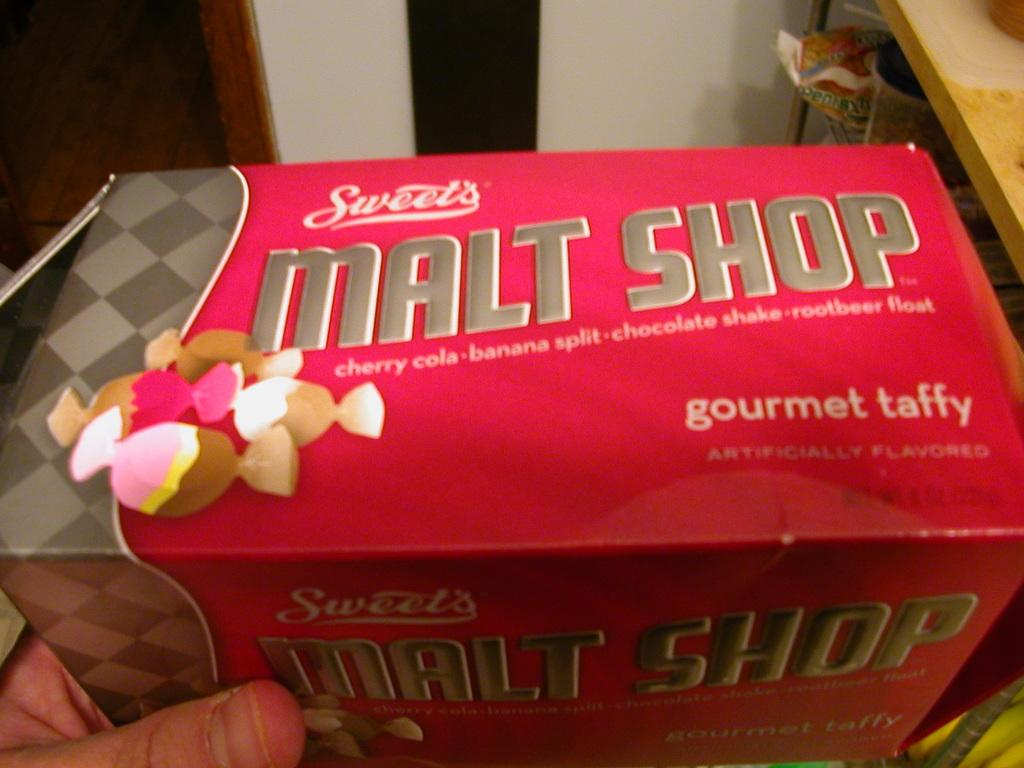What object is the main focus of the image? There is a box in the image. Can you describe any other visible elements in the image? A person's hand is visible in the left corner of the image, and there is a wooden and metal object in the right corner of the image. What can be seen in the background of the image? There appears to be a wall in the background of the image. How many boats are visible in the image? There are no boats present in the image. What type of tin is being used to store the wooden object? There is no tin present in the image; the wooden and metal object is not stored in any container. 